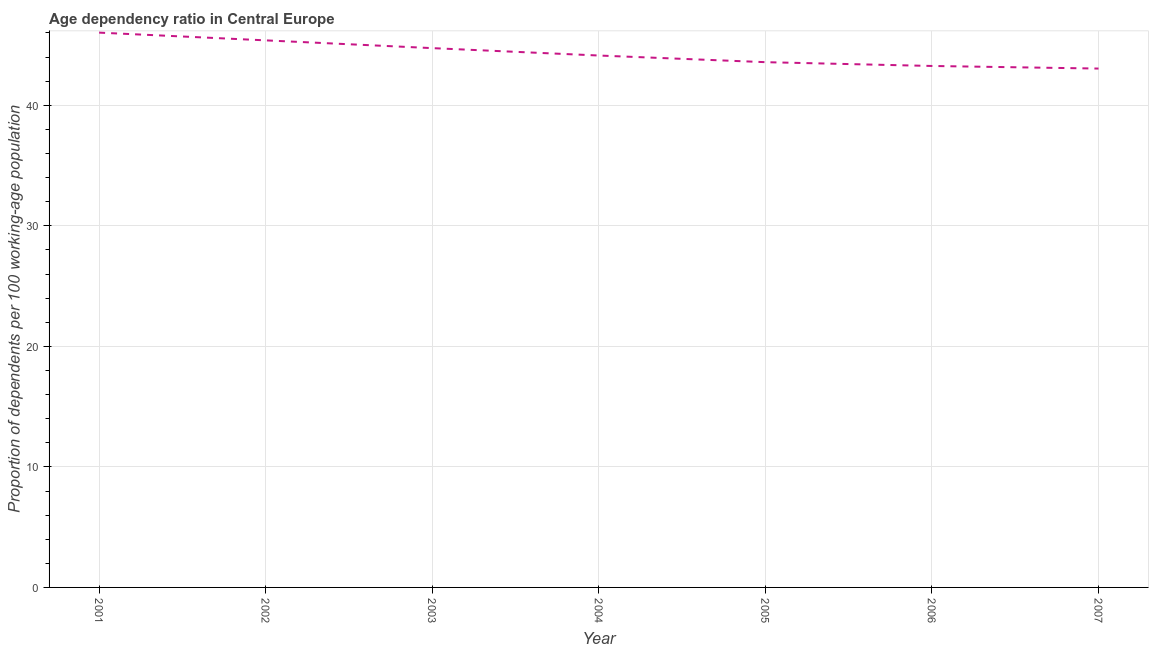What is the age dependency ratio in 2005?
Give a very brief answer. 43.58. Across all years, what is the maximum age dependency ratio?
Offer a very short reply. 46.03. Across all years, what is the minimum age dependency ratio?
Provide a succinct answer. 43.05. In which year was the age dependency ratio maximum?
Ensure brevity in your answer.  2001. In which year was the age dependency ratio minimum?
Make the answer very short. 2007. What is the sum of the age dependency ratio?
Keep it short and to the point. 310.18. What is the difference between the age dependency ratio in 2002 and 2004?
Your answer should be very brief. 1.26. What is the average age dependency ratio per year?
Keep it short and to the point. 44.31. What is the median age dependency ratio?
Offer a terse response. 44.13. In how many years, is the age dependency ratio greater than 16 ?
Provide a short and direct response. 7. Do a majority of the years between 2002 and 2005 (inclusive) have age dependency ratio greater than 18 ?
Give a very brief answer. Yes. What is the ratio of the age dependency ratio in 2003 to that in 2004?
Your response must be concise. 1.01. What is the difference between the highest and the second highest age dependency ratio?
Provide a succinct answer. 0.64. What is the difference between the highest and the lowest age dependency ratio?
Ensure brevity in your answer.  2.98. In how many years, is the age dependency ratio greater than the average age dependency ratio taken over all years?
Your answer should be very brief. 3. How many lines are there?
Offer a terse response. 1. Does the graph contain any zero values?
Your answer should be compact. No. What is the title of the graph?
Provide a short and direct response. Age dependency ratio in Central Europe. What is the label or title of the Y-axis?
Your response must be concise. Proportion of dependents per 100 working-age population. What is the Proportion of dependents per 100 working-age population in 2001?
Ensure brevity in your answer.  46.03. What is the Proportion of dependents per 100 working-age population in 2002?
Offer a terse response. 45.39. What is the Proportion of dependents per 100 working-age population in 2003?
Provide a short and direct response. 44.74. What is the Proportion of dependents per 100 working-age population in 2004?
Your answer should be very brief. 44.13. What is the Proportion of dependents per 100 working-age population of 2005?
Your answer should be compact. 43.58. What is the Proportion of dependents per 100 working-age population in 2006?
Offer a very short reply. 43.26. What is the Proportion of dependents per 100 working-age population of 2007?
Give a very brief answer. 43.05. What is the difference between the Proportion of dependents per 100 working-age population in 2001 and 2002?
Your response must be concise. 0.64. What is the difference between the Proportion of dependents per 100 working-age population in 2001 and 2003?
Your response must be concise. 1.29. What is the difference between the Proportion of dependents per 100 working-age population in 2001 and 2004?
Give a very brief answer. 1.9. What is the difference between the Proportion of dependents per 100 working-age population in 2001 and 2005?
Keep it short and to the point. 2.45. What is the difference between the Proportion of dependents per 100 working-age population in 2001 and 2006?
Offer a very short reply. 2.77. What is the difference between the Proportion of dependents per 100 working-age population in 2001 and 2007?
Provide a short and direct response. 2.98. What is the difference between the Proportion of dependents per 100 working-age population in 2002 and 2003?
Provide a succinct answer. 0.64. What is the difference between the Proportion of dependents per 100 working-age population in 2002 and 2004?
Your response must be concise. 1.26. What is the difference between the Proportion of dependents per 100 working-age population in 2002 and 2005?
Ensure brevity in your answer.  1.81. What is the difference between the Proportion of dependents per 100 working-age population in 2002 and 2006?
Ensure brevity in your answer.  2.12. What is the difference between the Proportion of dependents per 100 working-age population in 2002 and 2007?
Offer a terse response. 2.34. What is the difference between the Proportion of dependents per 100 working-age population in 2003 and 2004?
Your response must be concise. 0.61. What is the difference between the Proportion of dependents per 100 working-age population in 2003 and 2005?
Keep it short and to the point. 1.16. What is the difference between the Proportion of dependents per 100 working-age population in 2003 and 2006?
Offer a terse response. 1.48. What is the difference between the Proportion of dependents per 100 working-age population in 2003 and 2007?
Make the answer very short. 1.7. What is the difference between the Proportion of dependents per 100 working-age population in 2004 and 2005?
Make the answer very short. 0.55. What is the difference between the Proportion of dependents per 100 working-age population in 2004 and 2006?
Your answer should be compact. 0.87. What is the difference between the Proportion of dependents per 100 working-age population in 2004 and 2007?
Your answer should be compact. 1.08. What is the difference between the Proportion of dependents per 100 working-age population in 2005 and 2006?
Ensure brevity in your answer.  0.32. What is the difference between the Proportion of dependents per 100 working-age population in 2005 and 2007?
Your response must be concise. 0.53. What is the difference between the Proportion of dependents per 100 working-age population in 2006 and 2007?
Ensure brevity in your answer.  0.22. What is the ratio of the Proportion of dependents per 100 working-age population in 2001 to that in 2002?
Your answer should be compact. 1.01. What is the ratio of the Proportion of dependents per 100 working-age population in 2001 to that in 2003?
Give a very brief answer. 1.03. What is the ratio of the Proportion of dependents per 100 working-age population in 2001 to that in 2004?
Give a very brief answer. 1.04. What is the ratio of the Proportion of dependents per 100 working-age population in 2001 to that in 2005?
Your answer should be compact. 1.06. What is the ratio of the Proportion of dependents per 100 working-age population in 2001 to that in 2006?
Keep it short and to the point. 1.06. What is the ratio of the Proportion of dependents per 100 working-age population in 2001 to that in 2007?
Provide a short and direct response. 1.07. What is the ratio of the Proportion of dependents per 100 working-age population in 2002 to that in 2004?
Your answer should be compact. 1.03. What is the ratio of the Proportion of dependents per 100 working-age population in 2002 to that in 2005?
Your response must be concise. 1.04. What is the ratio of the Proportion of dependents per 100 working-age population in 2002 to that in 2006?
Your answer should be compact. 1.05. What is the ratio of the Proportion of dependents per 100 working-age population in 2002 to that in 2007?
Provide a succinct answer. 1.05. What is the ratio of the Proportion of dependents per 100 working-age population in 2003 to that in 2004?
Your answer should be compact. 1.01. What is the ratio of the Proportion of dependents per 100 working-age population in 2003 to that in 2005?
Give a very brief answer. 1.03. What is the ratio of the Proportion of dependents per 100 working-age population in 2003 to that in 2006?
Your answer should be very brief. 1.03. What is the ratio of the Proportion of dependents per 100 working-age population in 2003 to that in 2007?
Provide a succinct answer. 1.04. What is the ratio of the Proportion of dependents per 100 working-age population in 2004 to that in 2006?
Make the answer very short. 1.02. What is the ratio of the Proportion of dependents per 100 working-age population in 2004 to that in 2007?
Keep it short and to the point. 1.02. 